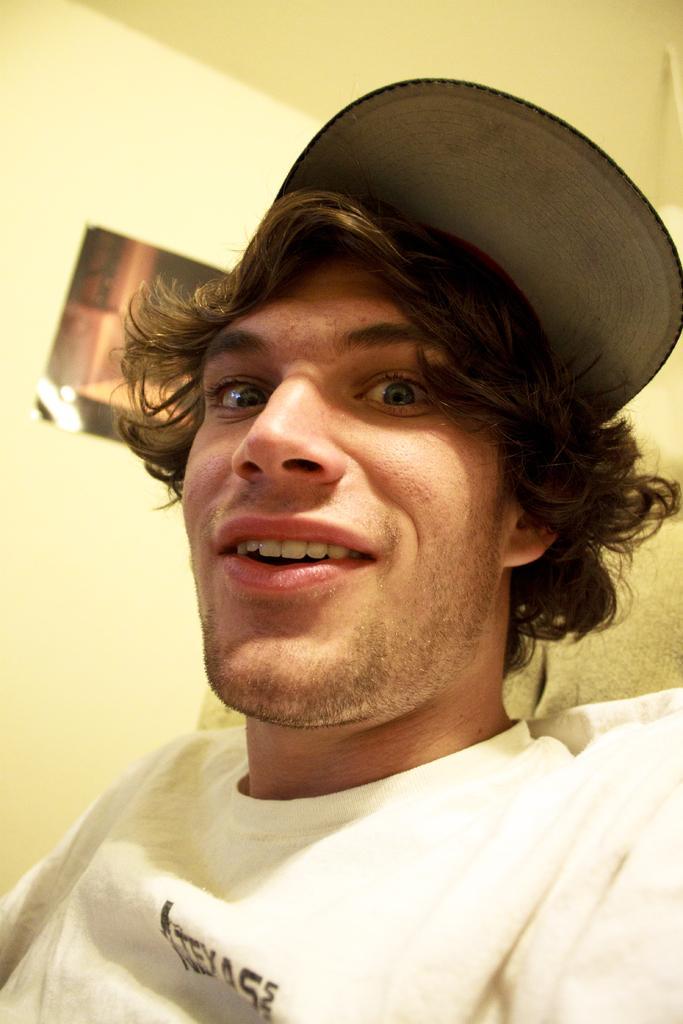In one or two sentences, can you explain what this image depicts? In this image, we can see a man is seeing and smiling. He is wearing a white t-shirt. Background there is a wall, poster. Top of the image, there is a ceiling. Here we can see a cloth. 